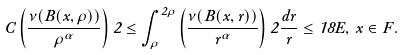<formula> <loc_0><loc_0><loc_500><loc_500>C \left ( \frac { \nu ( B ( x , \rho ) ) } { \rho ^ { \alpha } } \right ) 2 \leq \int _ { \rho } ^ { 2 \rho } \left ( \frac { \nu ( B ( x , r ) ) } { r ^ { \alpha } } \right ) 2 \frac { d r } r \leq 1 8 E , \, x \in F .</formula> 